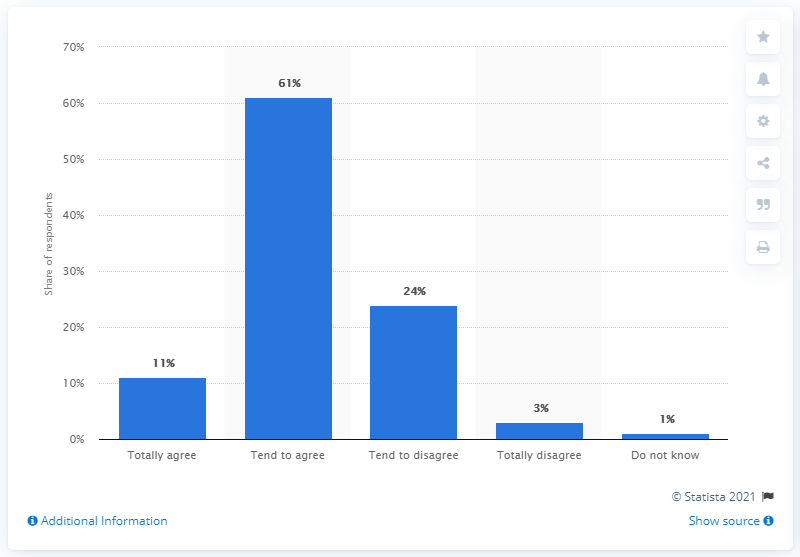Indicate a few pertinent items in this graphic. The value of the tallest bar is 61. The result of adding all agree opinions and disagree opinions together is greater than the number of people who do not know by a significant amount. 